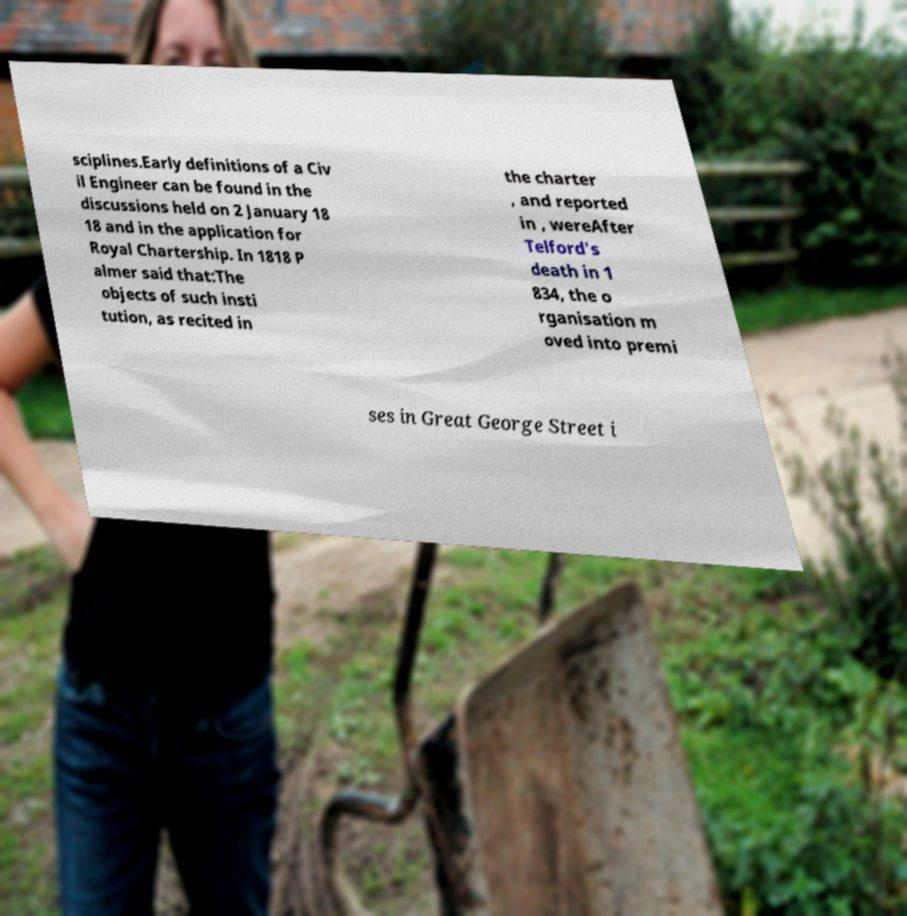Can you read and provide the text displayed in the image?This photo seems to have some interesting text. Can you extract and type it out for me? sciplines.Early definitions of a Civ il Engineer can be found in the discussions held on 2 January 18 18 and in the application for Royal Chartership. In 1818 P almer said that:The objects of such insti tution, as recited in the charter , and reported in , wereAfter Telford's death in 1 834, the o rganisation m oved into premi ses in Great George Street i 